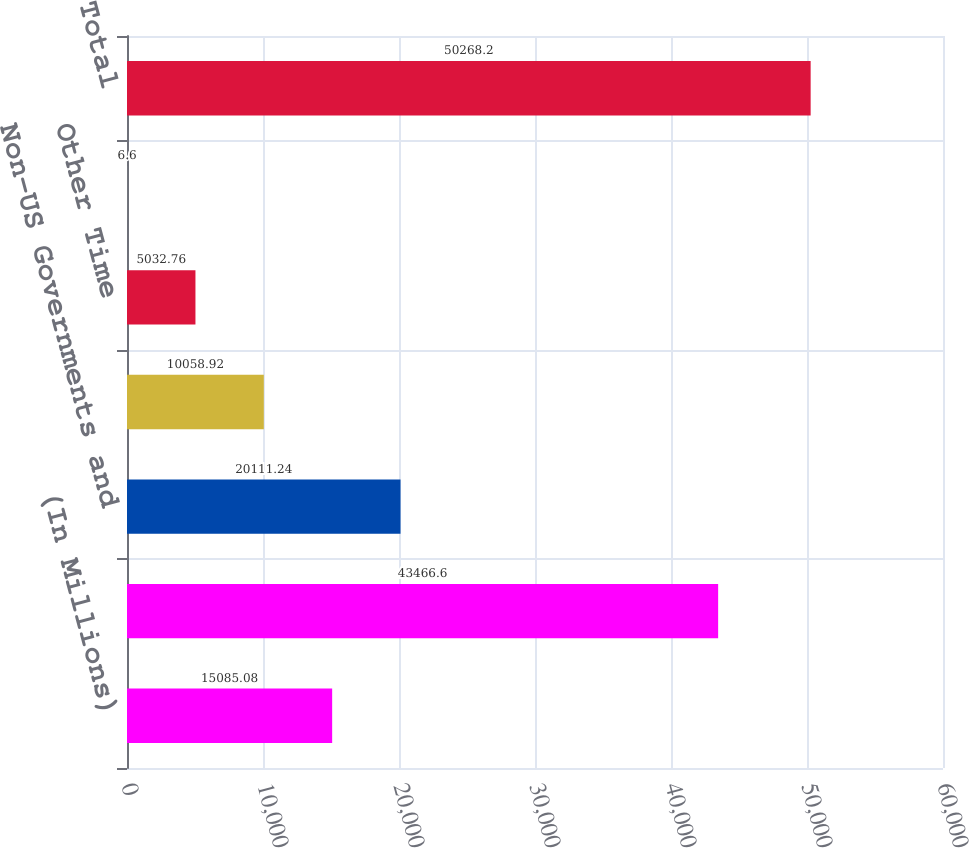Convert chart to OTSL. <chart><loc_0><loc_0><loc_500><loc_500><bar_chart><fcel>(In Millions)<fcel>Commercial<fcel>Non-US Governments and<fcel>Banks<fcel>Other Time<fcel>Other Demand<fcel>Total<nl><fcel>15085.1<fcel>43466.6<fcel>20111.2<fcel>10058.9<fcel>5032.76<fcel>6.6<fcel>50268.2<nl></chart> 